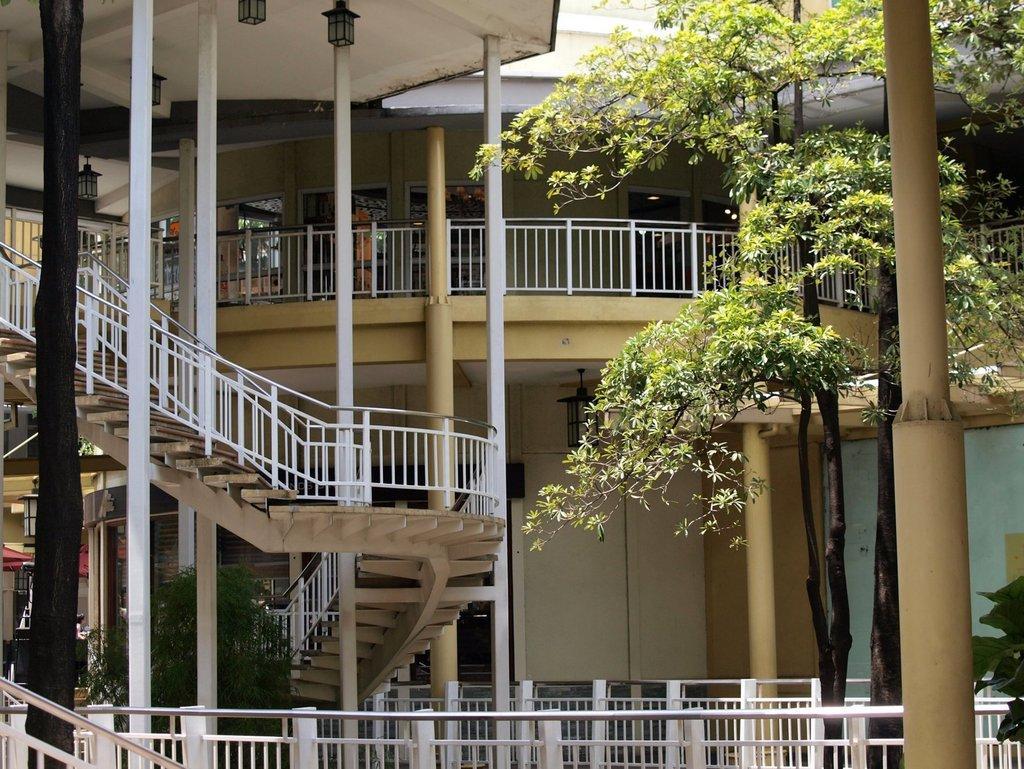Please provide a concise description of this image. In the foreground of the picture there are pole, tree and railings. In the center of the picture there are trees, staircases, railing, buildings and a person. At the top there are lights. 